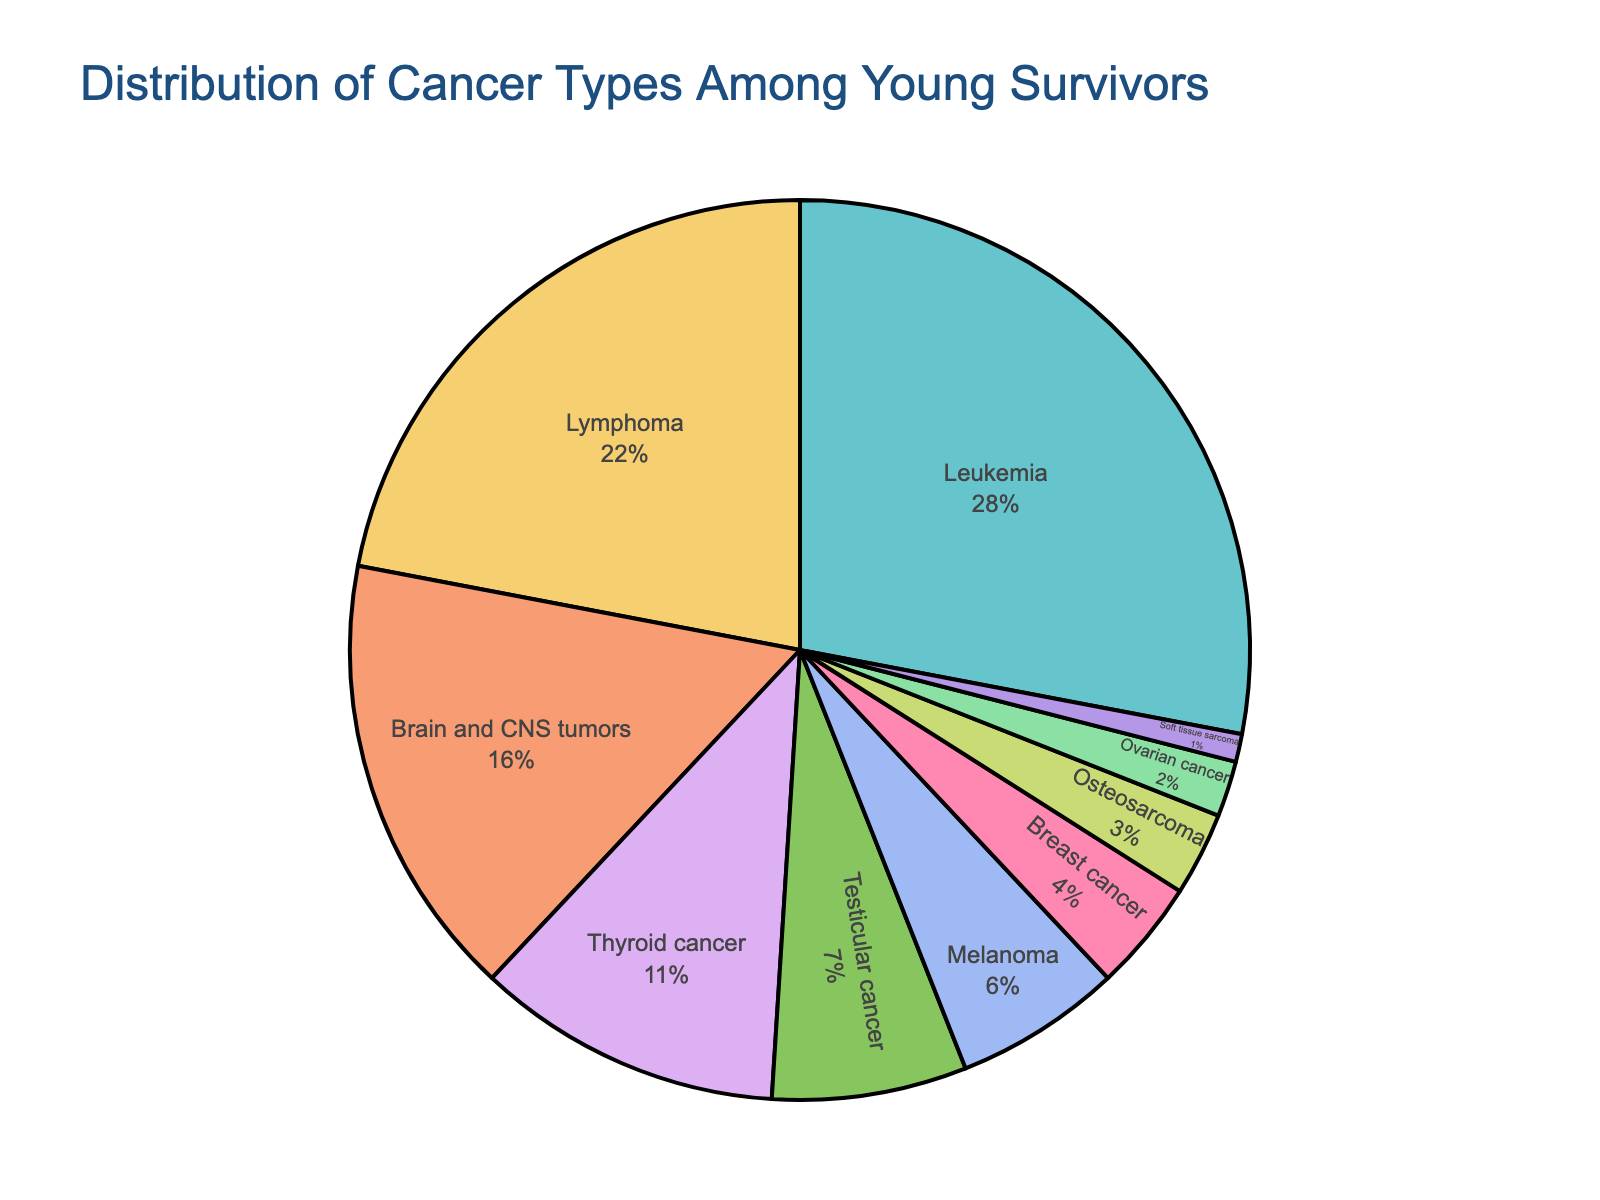What is the most common type of cancer among young survivors? The pie chart shows the different cancer types and their percentages. The cancer type with the highest percentage is the most common.
Answer: Leukemia Which cancer type has a higher percentage, Lymphoma or Brain and CNS tumors? By comparing the percentages shown in the pie chart, Lymphoma has 22% and Brain and CNS tumors have 16%.
Answer: Lymphoma What is the combined percentage of the top three most common cancer types? The top three cancer types are Leukemia (28%), Lymphoma (22%), and Brain and CNS tumors (16%). Adding these percentages together: 28% + 22% + 16% = 66%.
Answer: 66% Which cancer has a smaller percentage, Testicular cancer or Ovarian cancer? By comparing the percentages in the pie chart, Testicular cancer has 7% whereas Ovarian cancer has 2%.
Answer: Ovarian cancer What percentage of the pie chart is made up of cancers with percentages less than 10%? By examining the chart, the cancers with percentages less than 10% are Testicular cancer (7%), Melanoma (6%), Breast cancer (4%), Osteosarcoma (3%), Ovarian cancer (2%), and Soft tissue sarcoma (1%). Adding these together: 7% + 6% + 4% + 3% + 2% + 1% = 23%.
Answer: 23% Is the percentage of Thyroid cancer greater than Melanoma and Breast cancer combined? Thyroid cancer is 11%. Combining Melanoma (6%) and Breast cancer (4%) gives 6% + 4% = 10%. 11% is greater than 10%.
Answer: Yes What is the least common type of cancer among young survivors? The pie chart displays the various cancer types and their percentages. The cancer type with the smallest percentage is the least common.
Answer: Soft tissue sarcoma How much greater is the percentage of Leukemia compared to Testicular cancer? Leukemia has 28%, and Testicular cancer has 7%. The difference is 28% - 7% = 21%.
Answer: 21% What combination of three cancer types adds up to 51%? By evaluating the percentages, Leukemia (28%), Lymphoma (22%), and Soft tissue sarcoma (1%) together add up to 28% + 22% + 1% = 51%.
Answer: Leukemia, Lymphoma, Soft tissue sarcoma Are the combined percentages of Testicular cancer and Melanoma smaller than Brain and CNS tumors? Testicular cancer is 7% and Melanoma is 6%, adding them gives 7% + 6% = 13%. Brain and CNS tumors are 16%. 13% is smaller than 16%.
Answer: Yes 